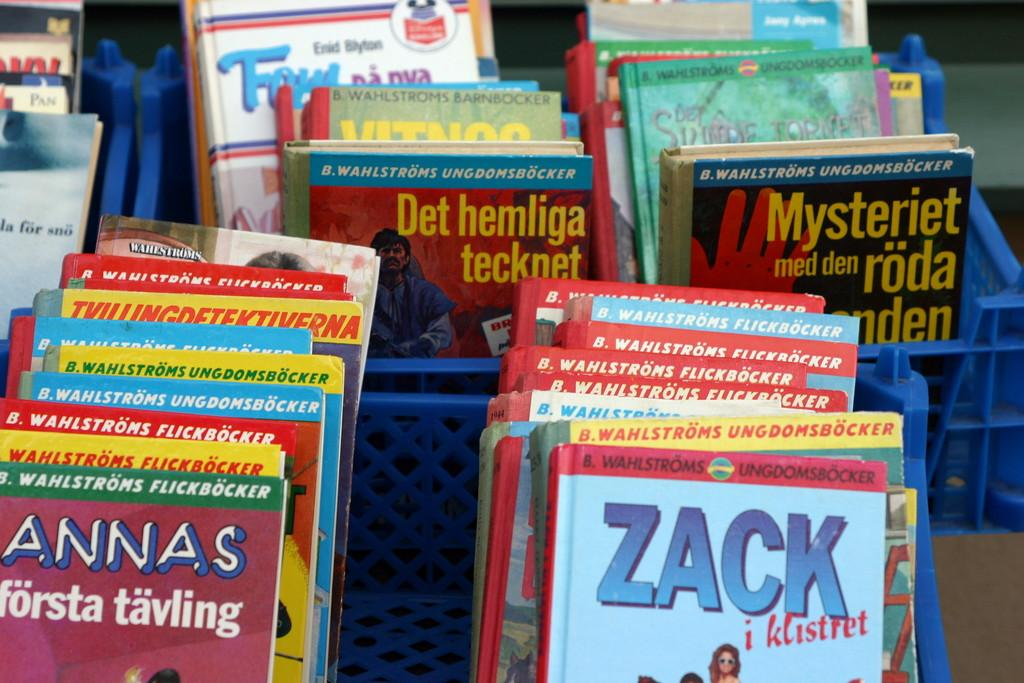What objects are present in the image? There are trays in the image. What color are the trays? The trays are blue in color. What items are stored in the trays? There are books in the trays. How do the books differ from one another? The books have different colors. Are there any blades visible in the image? No, there are no blades present in the image. Can you see any spiders crawling on the books in the image? No, there are no spiders visible in the image. 